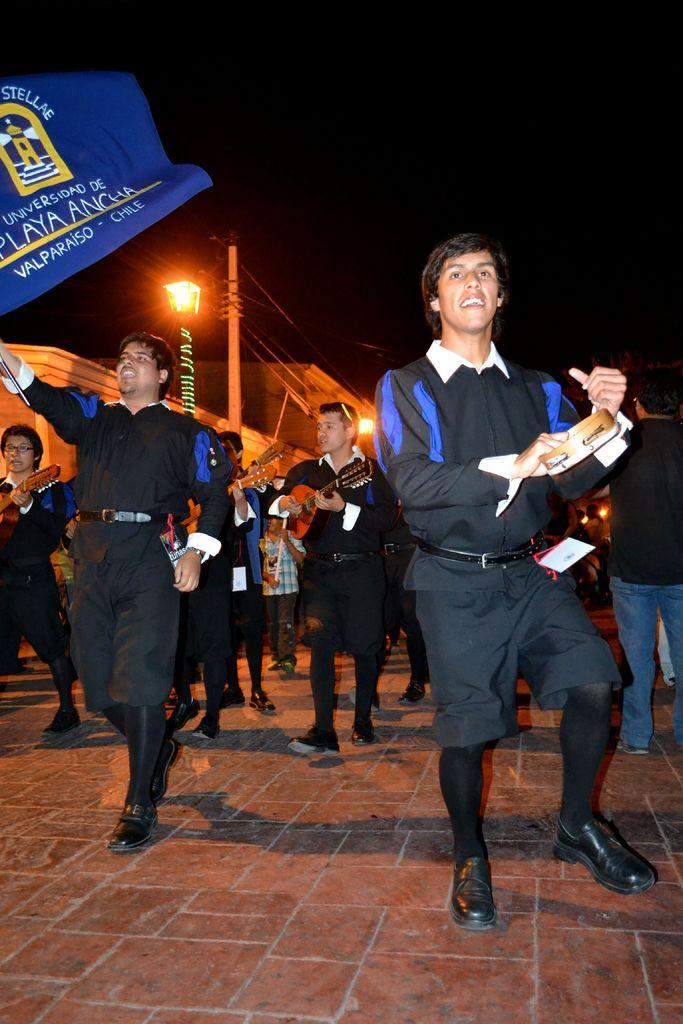What is happening in the image? There are people in the image, and they are walking on a footpath. What are the people carrying in their hands? The people are holding instruments in their hands. What can be seen in the background of the image? There are houses, a light pole, and an electrical pole in the background of the image. What type of beef can be seen being transported by boats in the image? There is no beef or boats present in the image; it features people walking on a footpath and holding instruments. 